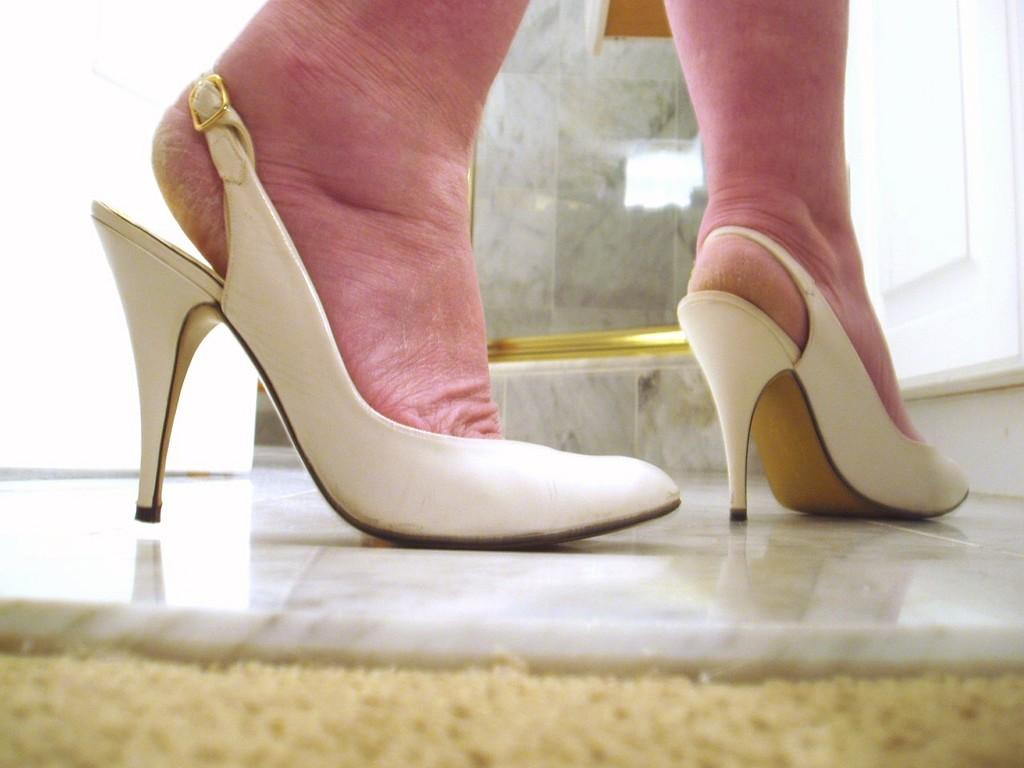What is the main focus of the image? The main focus of the image is a person's legs in the center. What type of footwear is the person wearing? The person is wearing heels. What can be seen in the background of the image? There is a wall, glass, and a door in the background of the image. What is the surface beneath the person's legs? There is a floor at the bottom of the image. What grade of sound can be heard in the image? There is no sound present in the image, so it is not possible to determine the grade of sound. 